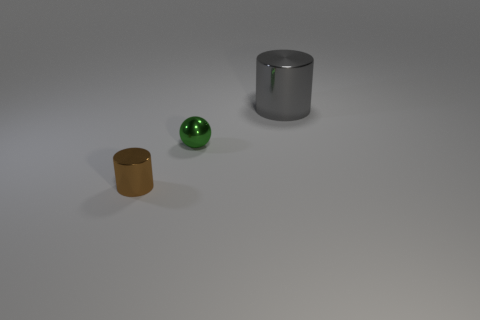The cylinder to the right of the tiny object behind the cylinder that is in front of the gray cylinder is made of what material?
Your response must be concise. Metal. There is a thing on the left side of the metal ball; does it have the same color as the metal thing that is behind the ball?
Provide a short and direct response. No. What is the shape of the small thing that is to the right of the metal cylinder in front of the thing on the right side of the small ball?
Give a very brief answer. Sphere. What shape is the shiny thing that is behind the tiny brown cylinder and in front of the gray cylinder?
Your answer should be very brief. Sphere. What number of small green shiny objects are to the left of the metal cylinder behind the cylinder on the left side of the gray metallic cylinder?
Ensure brevity in your answer.  1. What is the size of the other thing that is the same shape as the gray thing?
Offer a very short reply. Small. Is there anything else that has the same size as the gray thing?
Your response must be concise. No. Do the cylinder that is on the left side of the large gray thing and the tiny green sphere have the same material?
Your answer should be compact. Yes. The small metallic thing that is the same shape as the big thing is what color?
Your answer should be very brief. Brown. How many other things are there of the same color as the big metallic object?
Provide a short and direct response. 0. 